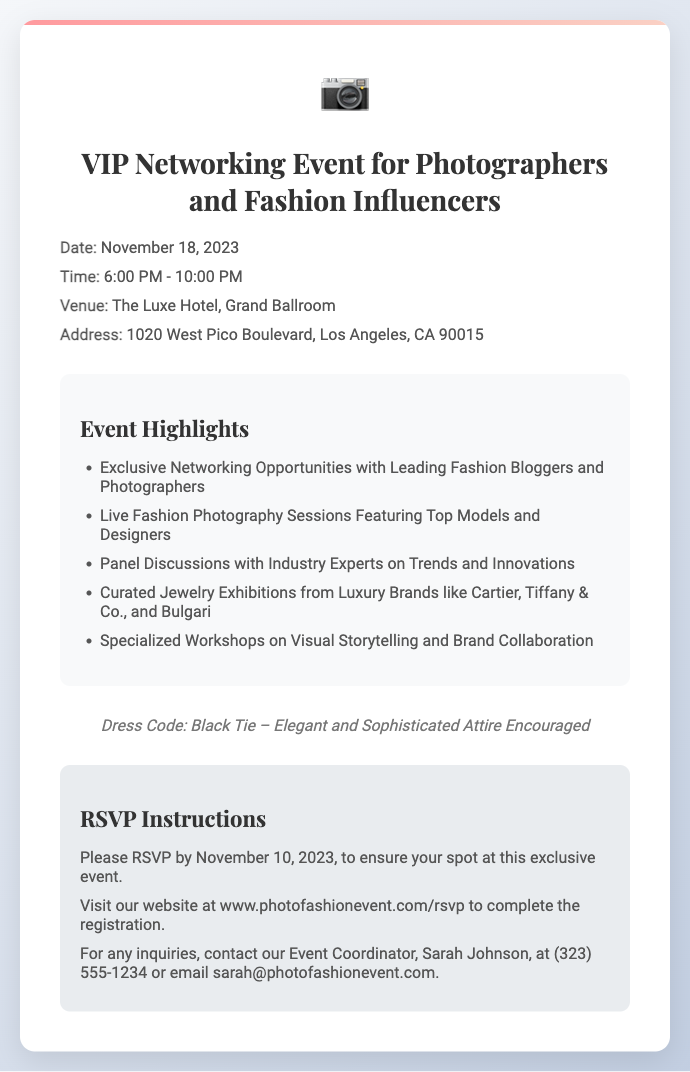what is the date of the event? The date is explicitly mentioned in the event details section of the document as November 18, 2023.
Answer: November 18, 2023 what is the venue for the networking event? The venue where the event will be held is given in the event details section as The Luxe Hotel, Grand Ballroom.
Answer: The Luxe Hotel, Grand Ballroom what is the dress code for the event? The dress code is indicated at the bottom of the card as Black Tie – Elegant and Sophisticated Attire Encouraged.
Answer: Black Tie who can you contact for inquiries? The contact person for inquiries is mentioned in the RSVP instructions as Sarah Johnson.
Answer: Sarah Johnson how many highlights are listed for the event? To find out, you count the number of items in the event highlights section, which lists five distinct highlights.
Answer: 5 what is the time frame of the event? The time of the event is provided in the event details section as 6:00 PM - 10:00 PM.
Answer: 6:00 PM - 10:00 PM by what date should you RSVP? The RSVP deadline is specified in the RSVP instructions as November 10, 2023.
Answer: November 10, 2023 what is emphasized as a key aspect of the event? The event highlights section includes exclusive networking opportunities, indicating the emphasis on networking.
Answer: Exclusive Networking Opportunities where can you complete the registration? The document specifies that registration can be completed on the website at www.photofashionevent.com/rsvp.
Answer: www.photofashionevent.com/rsvp 